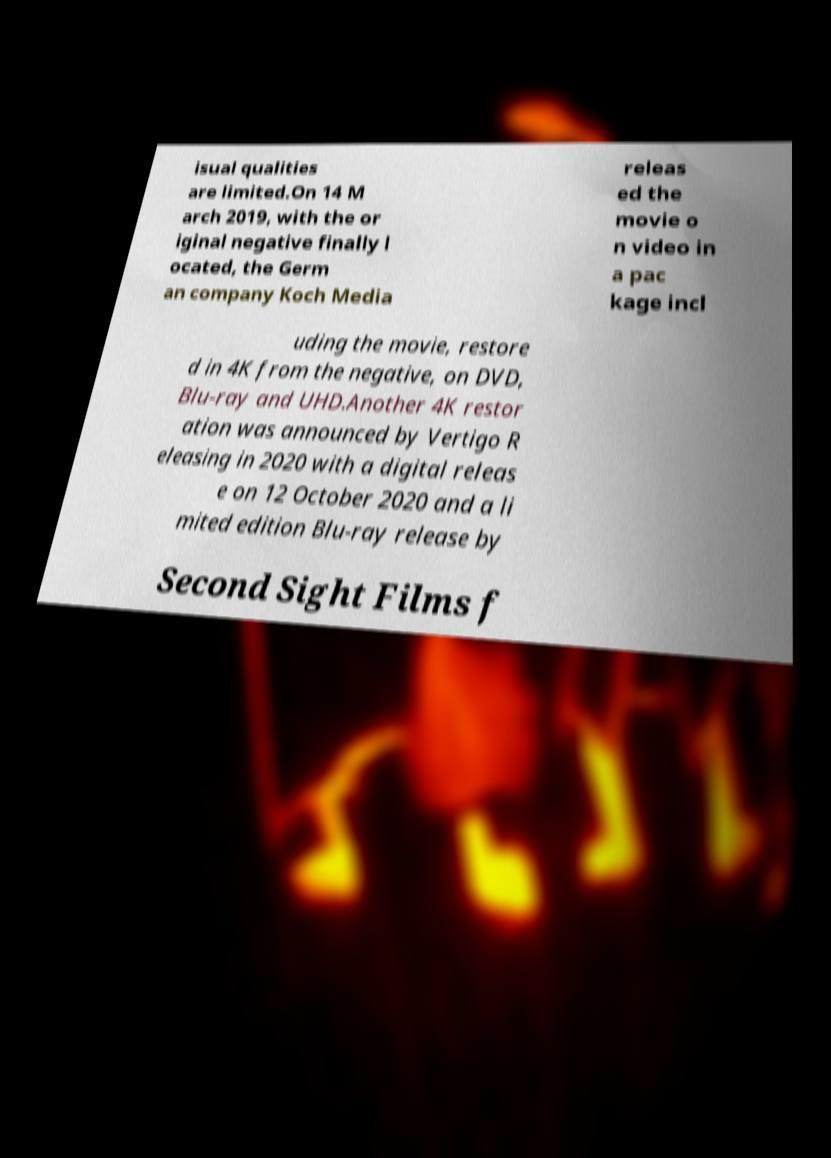Can you read and provide the text displayed in the image?This photo seems to have some interesting text. Can you extract and type it out for me? isual qualities are limited.On 14 M arch 2019, with the or iginal negative finally l ocated, the Germ an company Koch Media releas ed the movie o n video in a pac kage incl uding the movie, restore d in 4K from the negative, on DVD, Blu-ray and UHD.Another 4K restor ation was announced by Vertigo R eleasing in 2020 with a digital releas e on 12 October 2020 and a li mited edition Blu-ray release by Second Sight Films f 